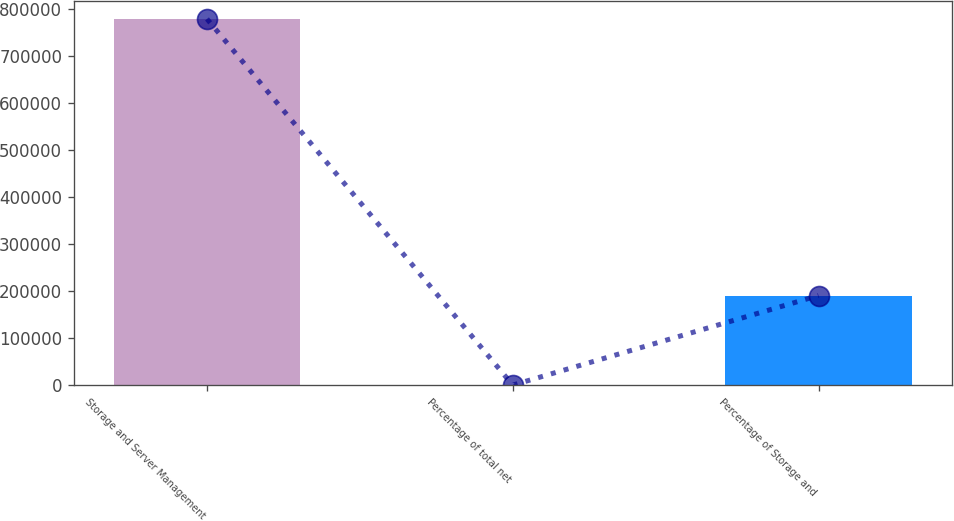<chart> <loc_0><loc_0><loc_500><loc_500><bar_chart><fcel>Storage and Server Management<fcel>Percentage of total net<fcel>Percentage of Storage and<nl><fcel>779573<fcel>37<fcel>190694<nl></chart> 